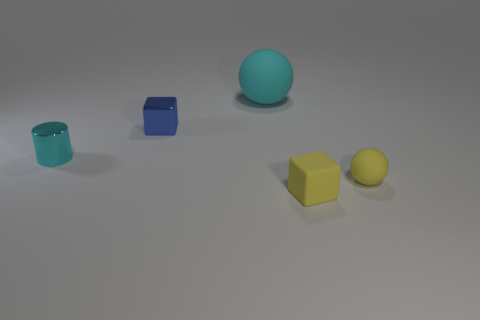Add 2 small brown matte objects. How many objects exist? 7 Subtract all balls. How many objects are left? 3 Subtract all cubes. Subtract all large brown metallic things. How many objects are left? 3 Add 5 yellow rubber things. How many yellow rubber things are left? 7 Add 3 cyan cylinders. How many cyan cylinders exist? 4 Subtract 0 blue cylinders. How many objects are left? 5 